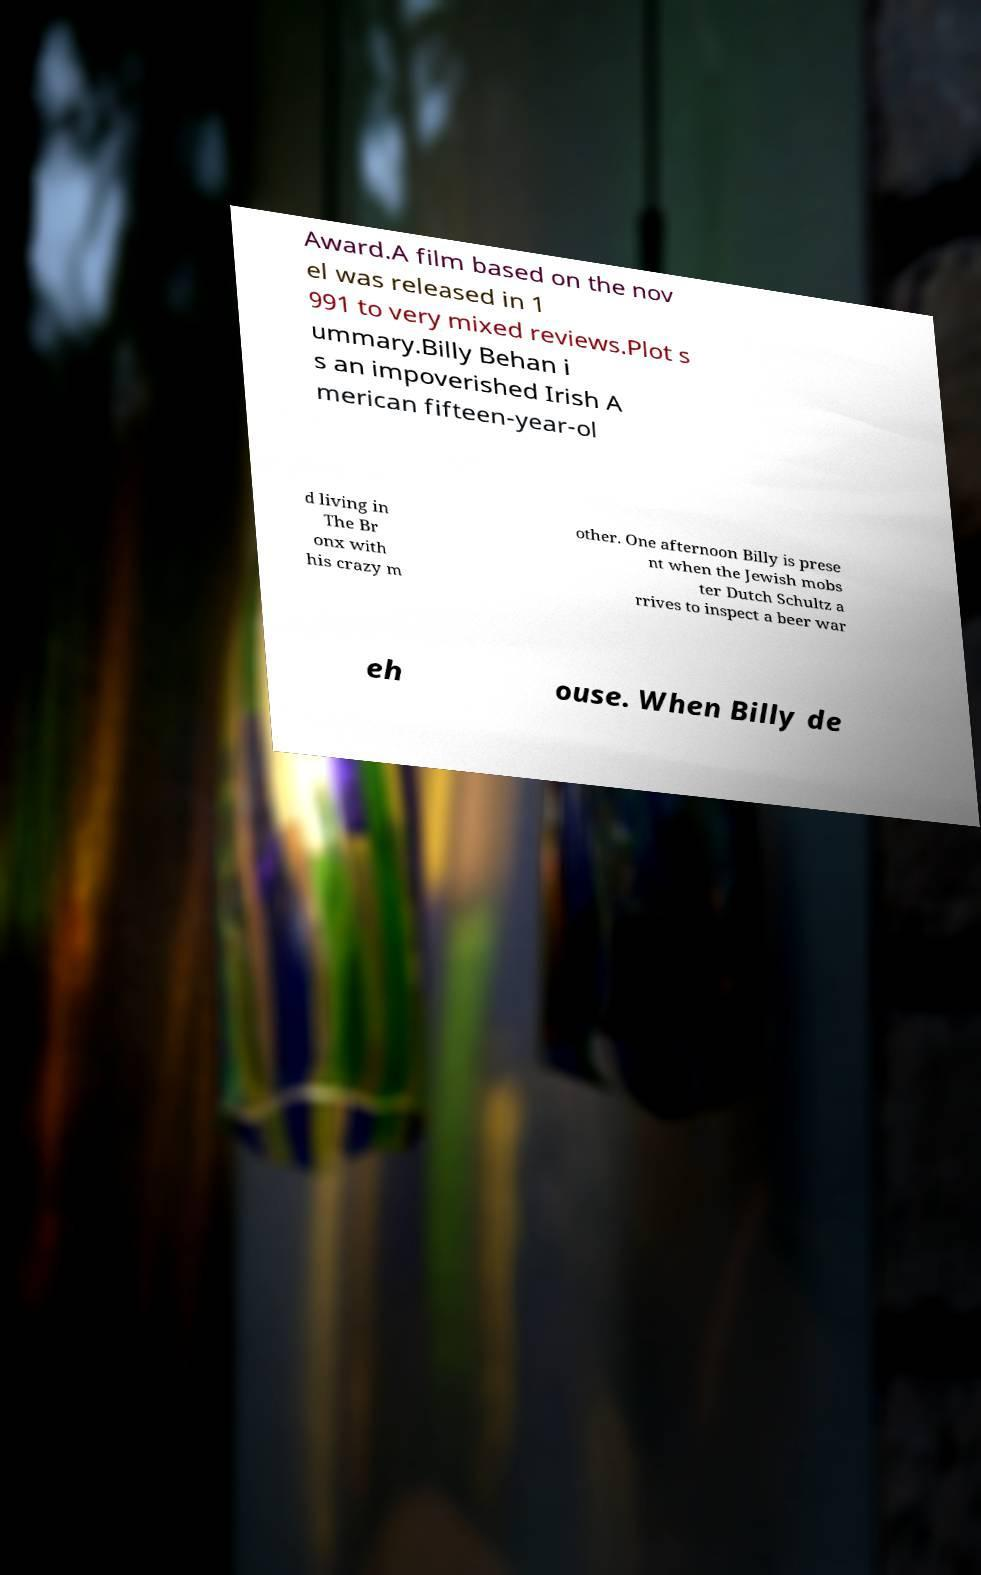Could you extract and type out the text from this image? Award.A film based on the nov el was released in 1 991 to very mixed reviews.Plot s ummary.Billy Behan i s an impoverished Irish A merican fifteen-year-ol d living in The Br onx with his crazy m other. One afternoon Billy is prese nt when the Jewish mobs ter Dutch Schultz a rrives to inspect a beer war eh ouse. When Billy de 